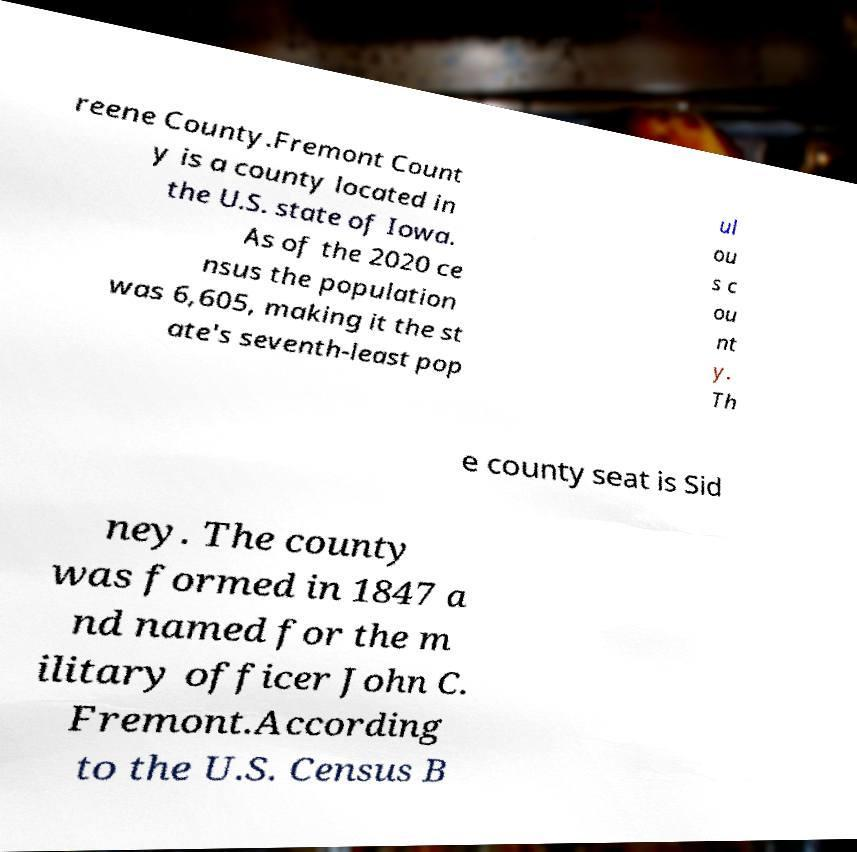Please read and relay the text visible in this image. What does it say? reene County.Fremont Count y is a county located in the U.S. state of Iowa. As of the 2020 ce nsus the population was 6,605, making it the st ate's seventh-least pop ul ou s c ou nt y. Th e county seat is Sid ney. The county was formed in 1847 a nd named for the m ilitary officer John C. Fremont.According to the U.S. Census B 